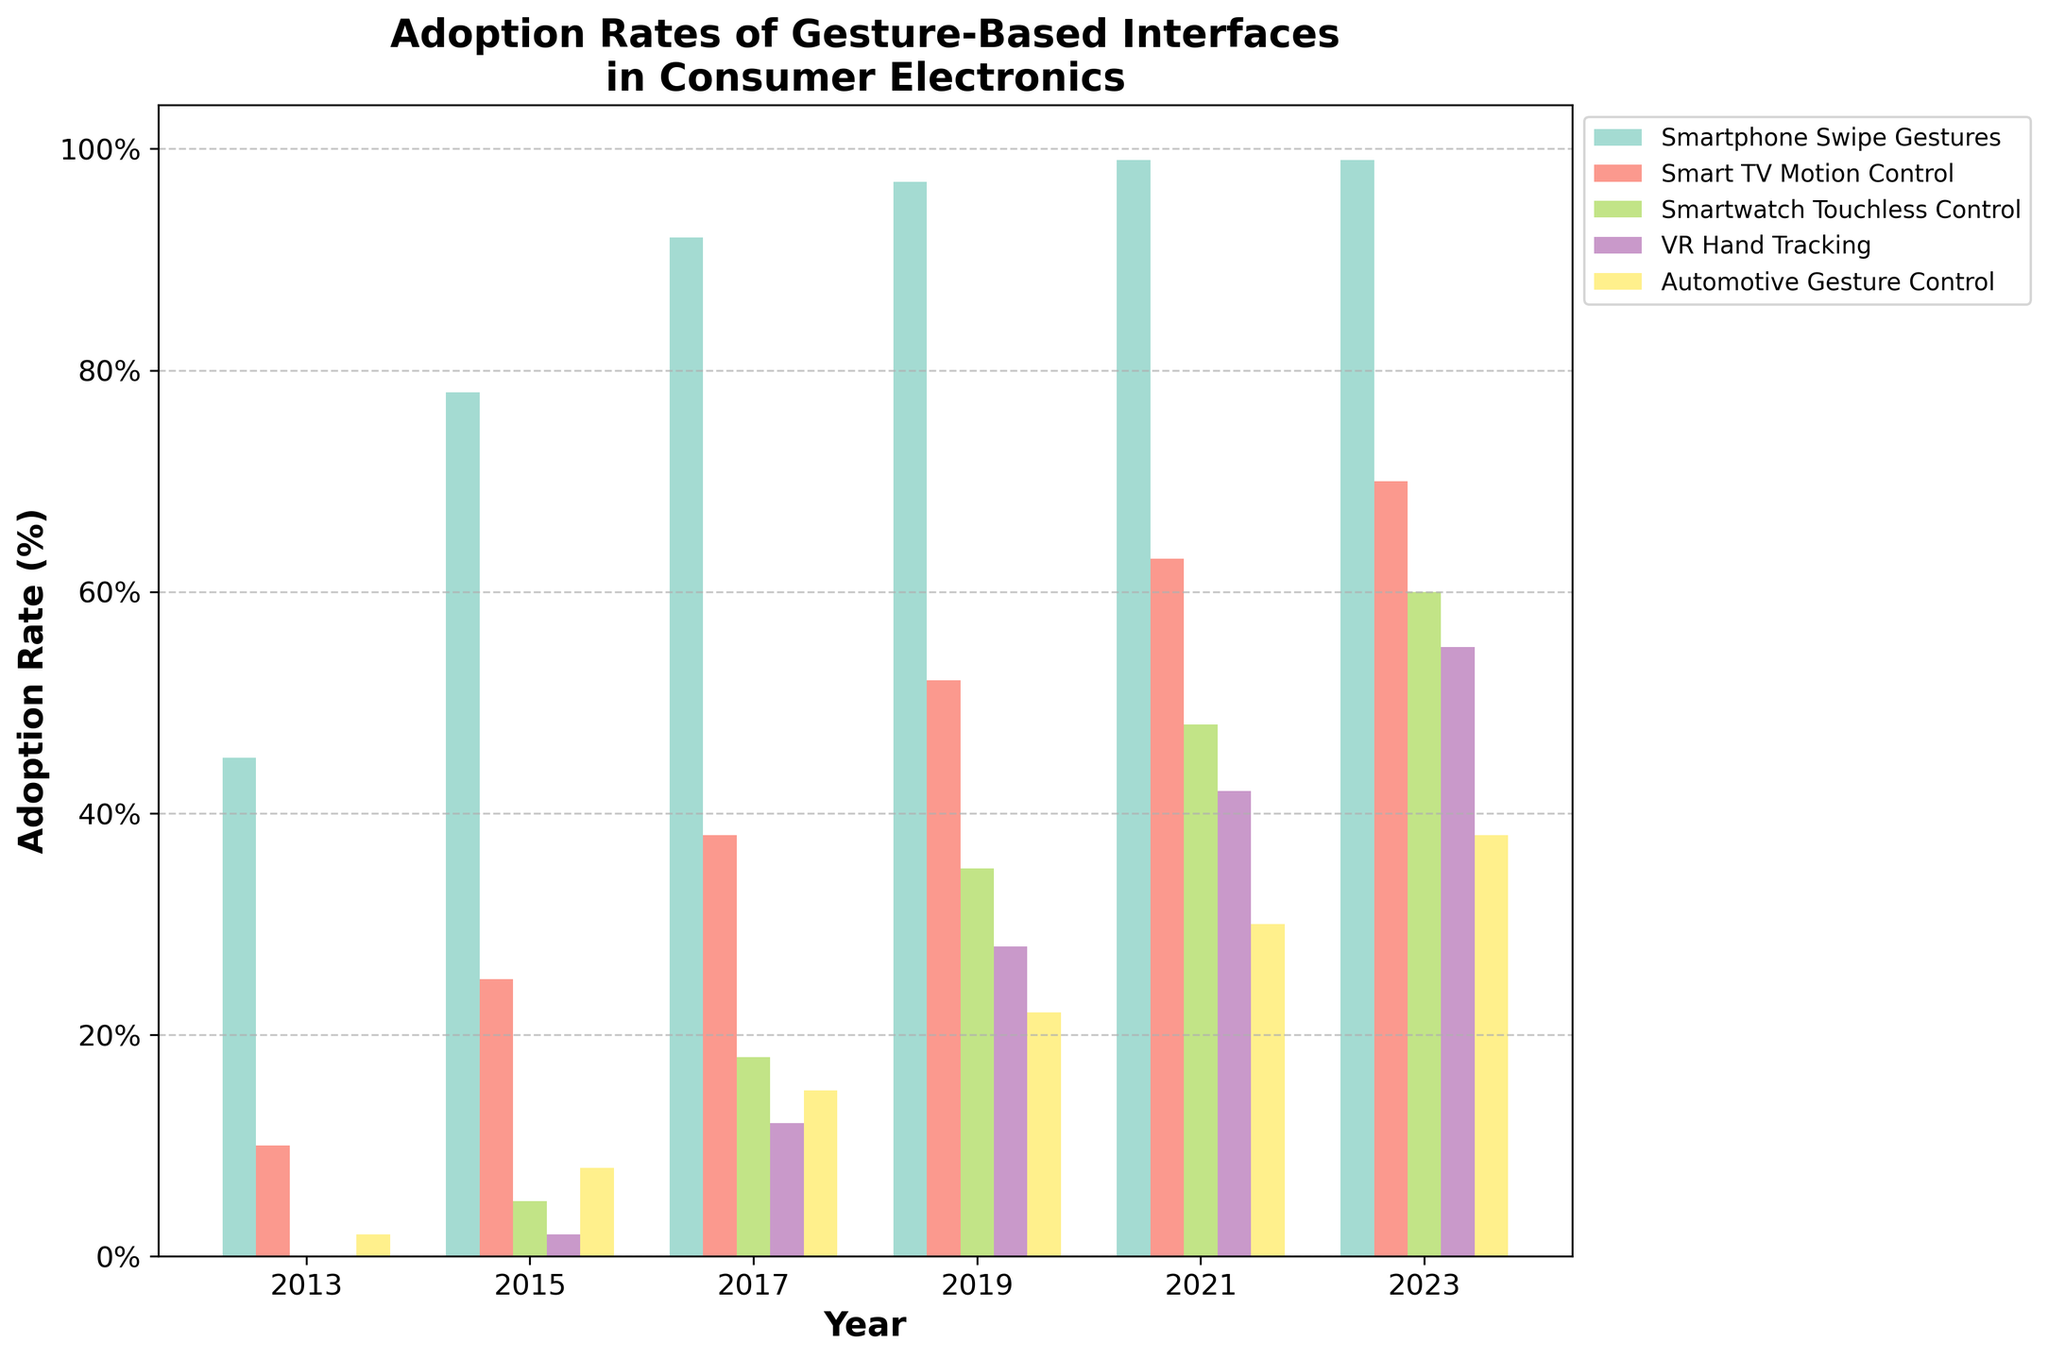Which gesture-based interface had the highest adoption rate in 2013? To find the highest adoption rate in 2013, look at the values for each interface in that year. The highest value is for "Smartphone Swipe Gestures" at 45%.
Answer: Smartphone Swipe Gestures Between 2015 and 2023, which interface shows the greatest increase in adoption rate? Calculate the difference in adoption rates for each interface between 2015 and 2023. "Smartphone Swipe Gestures" increased from 78% to 99% (21%), "Smart TV Motion Control" from 25% to 70% (45%), "Smartwatch Touchless Control" from 5% to 60% (55%), "VR Hand Tracking" from 2% to 55% (53%), and "Automotive Gesture Control" from 8% to 38% (30%). The greatest increase is "Smartwatch Touchless Control".
Answer: Smartwatch Touchless Control In which year did "VR Hand Tracking" surpass 20% adoption rate? Look for the first year where the bar representing "VR Hand Tracking" exceeds the 20% mark. This happens in 2019 when it reaches 28%.
Answer: 2019 Compare the adoption rates of "Smart TV Motion Control" and "Automotive Gesture Control" in 2021. Which one is higher and by how much? In 2021, "Smart TV Motion Control" is at 63% and "Automotive Gesture Control" is at 30%. The difference is 63% - 30% = 33%. "Smart TV Motion Control" is higher by 33%.
Answer: Smart TV Motion Control by 33% What is the average adoption rate of "Smartwatch Touchless Control" over the entire period? Sum the adoption rates of "Smartwatch Touchless Control" from each year: 0% + 5% + 18% + 35% + 48% + 60% = 166%. Divide this by the number of years (6): 166% / 6 = 27.67%.
Answer: 27.67% Which interface had the lowest adoption rate in 2023? Look at the values for each interface in 2023. "Automotive Gesture Control" has the lowest adoption rate at 38%.
Answer: Automotive Gesture Control How much did the adoption rate of "Smartphone Swipe Gestures" change from 2019 to 2023? In 2019, the rate is 97%, and in 2023, it is 99%. The change is 99% - 97% = 2%.
Answer: 2% What is the combined adoption rate of "Smart TV Motion Control" and "VR Hand Tracking" in 2019? Add the adoption rates of "Smart TV Motion Control" (52%) and "VR Hand Tracking" (28%) for 2019. 52% + 28% = 80%.
Answer: 80% Which years saw the adoption rate of "Automotive Gesture Control" rise above 20%? Check each year's adoption rate for "Automotive Gesture Control". In 2017 it was 15%, in 2019 it was 22%, in 2021 it was 30%, and in 2023 it was 38%. So, the years are 2019, 2021, and 2023.
Answer: 2019, 2021, 2023 